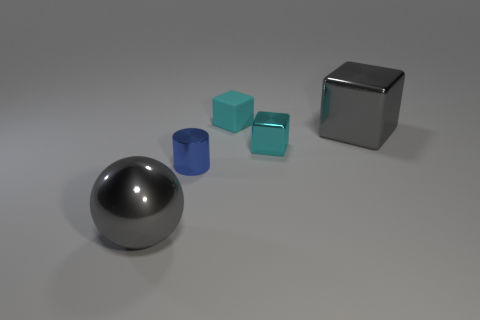Subtract 1 blocks. How many blocks are left? 2 Add 2 gray metallic blocks. How many objects exist? 7 Subtract all cubes. How many objects are left? 2 Subtract all small red metal cylinders. Subtract all small things. How many objects are left? 2 Add 5 gray cubes. How many gray cubes are left? 6 Add 3 things. How many things exist? 8 Subtract 0 gray cylinders. How many objects are left? 5 